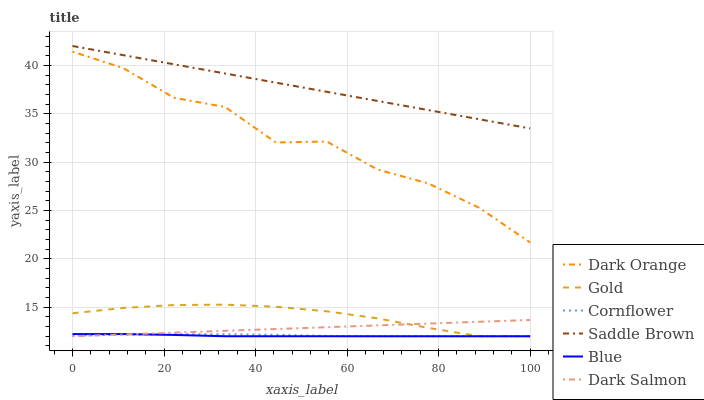Does Blue have the minimum area under the curve?
Answer yes or no. Yes. Does Saddle Brown have the maximum area under the curve?
Answer yes or no. Yes. Does Dark Orange have the minimum area under the curve?
Answer yes or no. No. Does Dark Orange have the maximum area under the curve?
Answer yes or no. No. Is Dark Salmon the smoothest?
Answer yes or no. Yes. Is Dark Orange the roughest?
Answer yes or no. Yes. Is Gold the smoothest?
Answer yes or no. No. Is Gold the roughest?
Answer yes or no. No. Does Blue have the lowest value?
Answer yes or no. Yes. Does Dark Orange have the lowest value?
Answer yes or no. No. Does Saddle Brown have the highest value?
Answer yes or no. Yes. Does Dark Orange have the highest value?
Answer yes or no. No. Is Cornflower less than Dark Orange?
Answer yes or no. Yes. Is Dark Orange greater than Cornflower?
Answer yes or no. Yes. Does Cornflower intersect Gold?
Answer yes or no. Yes. Is Cornflower less than Gold?
Answer yes or no. No. Is Cornflower greater than Gold?
Answer yes or no. No. Does Cornflower intersect Dark Orange?
Answer yes or no. No. 